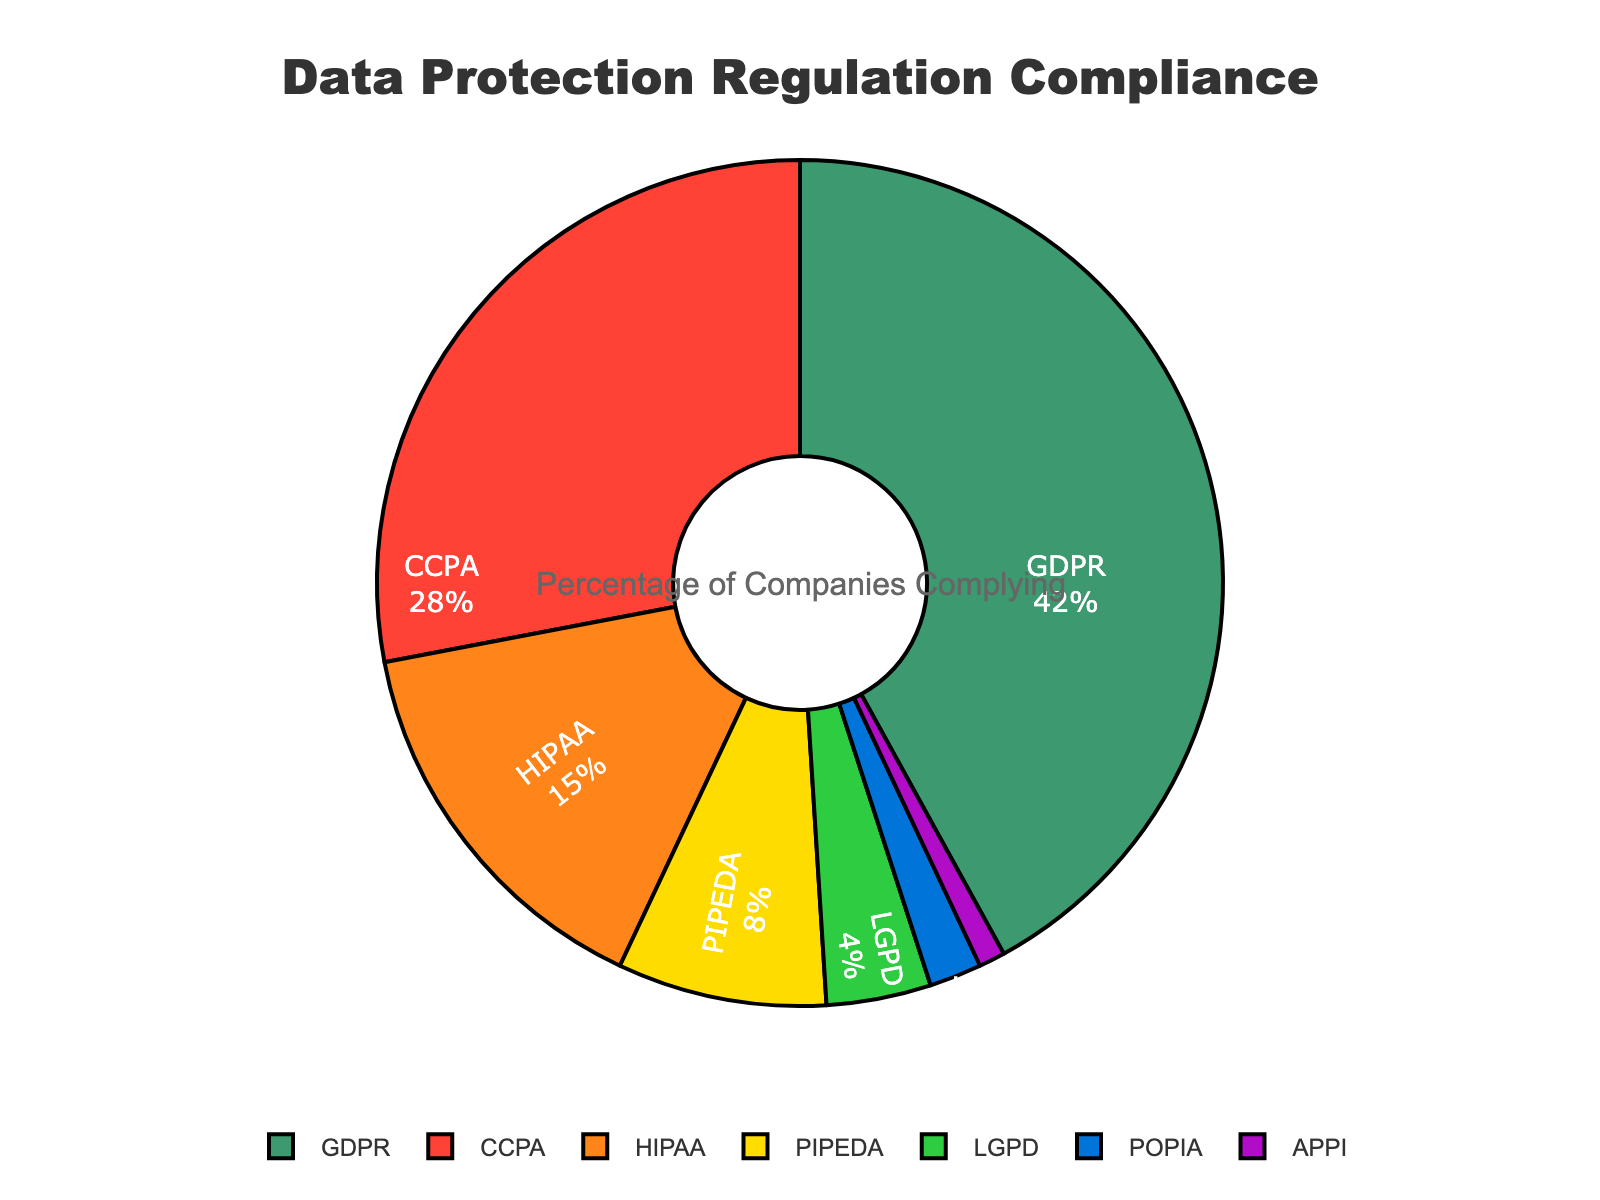What percentage of companies comply with the GDPR? The GDPR compliance percentage is labeled on the chart.
Answer: 42% How does the percentage of companies complying with GDPR compare to those complying with CCPA? Look at the chart and compare the percentages for GDPR and CCPA. GDPR compliance is 42% while CCPA compliance is 28%.
Answer: GDPR has a higher compliance percentage than CCPA What is the combined percentage of companies complying with HIPAA and PIPEDA? Add the percentages of HIPAA and PIPEDA. HIPAA is 15% and PIPEDA is 8%. Therefore, 15% + 8% = 23%.
Answer: 23% Which regulation has the lowest compliance percentage, and what is it? Identify the sector with the smallest value. APPI has the lowest compliance percentage.
Answer: APPI, 1% What is the difference in compliance percentage between the regulation with the highest compliance and the regulation with the lowest compliance? Find the highest percentage (GDPR at 42%) and the lowest (APPI at 1%) and subtract the latter from the former: 42% - 1% = 41%.
Answer: 41% Which regulations have compliance percentages higher than 20%? Look for segments with values exceeding 20%. GDPR at 42% and CCPA at 28% exceed 20%.
Answer: GDPR and CCPA Is the compliance percentage of PIPEDA more or less than half of the GDPR compliance percentage? Half of GDPR's compliance percentage is 21%. Compare this with PIPEDA's 8%. 8% is less than 21%.
Answer: Less Which segment is represented by the green color? Identify the color that corresponds to the segment labeled with the green color. The green segment represents GDPR.
Answer: GDPR How does the compliance percentage of LGPD compare to that of PIPEDA and POPIA combined? First calculate PIPEDA and POPIA combined: 8% + 2% = 10%. LGPD is 4%. Therefore, LGPD's 4% is less than their combined 10%.
Answer: Less What is the average compliance percentage of HIPAA, PIPEDA, and LGPD? Sum the percentages of HIPAA (15%), PIPEDA (8%), and LGPD (4%) to get 27%. Divide by the number of regulations, which is 3. So, 27% / 3 = 9%.
Answer: 9% 